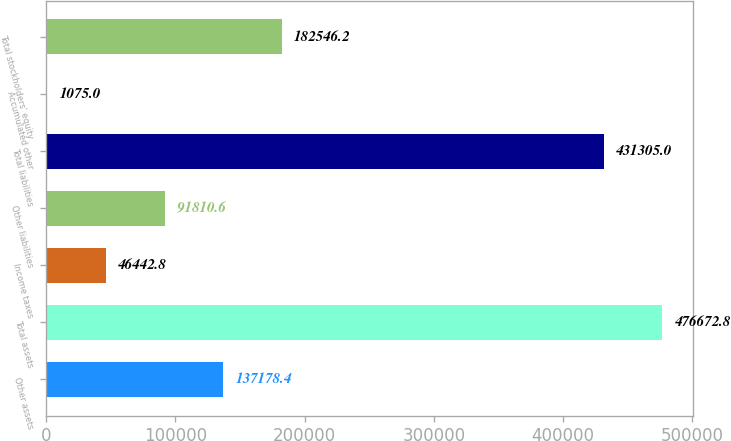Convert chart to OTSL. <chart><loc_0><loc_0><loc_500><loc_500><bar_chart><fcel>Other assets<fcel>Total assets<fcel>Income taxes<fcel>Other liabilities<fcel>Total liabilities<fcel>Accumulated other<fcel>Total stockholders' equity<nl><fcel>137178<fcel>476673<fcel>46442.8<fcel>91810.6<fcel>431305<fcel>1075<fcel>182546<nl></chart> 